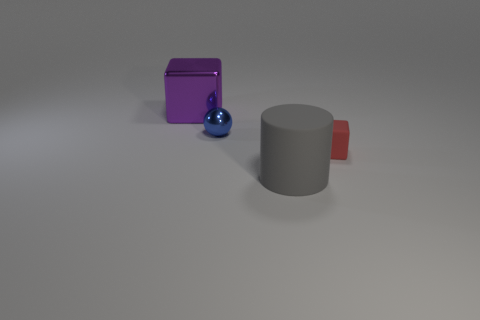What number of other things are the same material as the big gray cylinder?
Keep it short and to the point. 1. Is the color of the cube on the right side of the big cylinder the same as the large thing that is in front of the big cube?
Offer a very short reply. No. What is the material of the small thing that is left of the object in front of the thing that is right of the rubber cylinder?
Give a very brief answer. Metal. Is there a rubber object of the same size as the matte cube?
Your answer should be compact. No. What material is the ball that is the same size as the matte block?
Your answer should be compact. Metal. There is a metal object on the right side of the big purple thing; what is its shape?
Your answer should be compact. Sphere. Does the block that is right of the big gray cylinder have the same material as the block behind the sphere?
Your answer should be very brief. No. What number of tiny metal objects are the same shape as the tiny matte object?
Ensure brevity in your answer.  0. What number of objects are either tiny cyan metal cubes or metal objects in front of the large purple block?
Offer a very short reply. 1. What is the tiny blue ball made of?
Make the answer very short. Metal. 